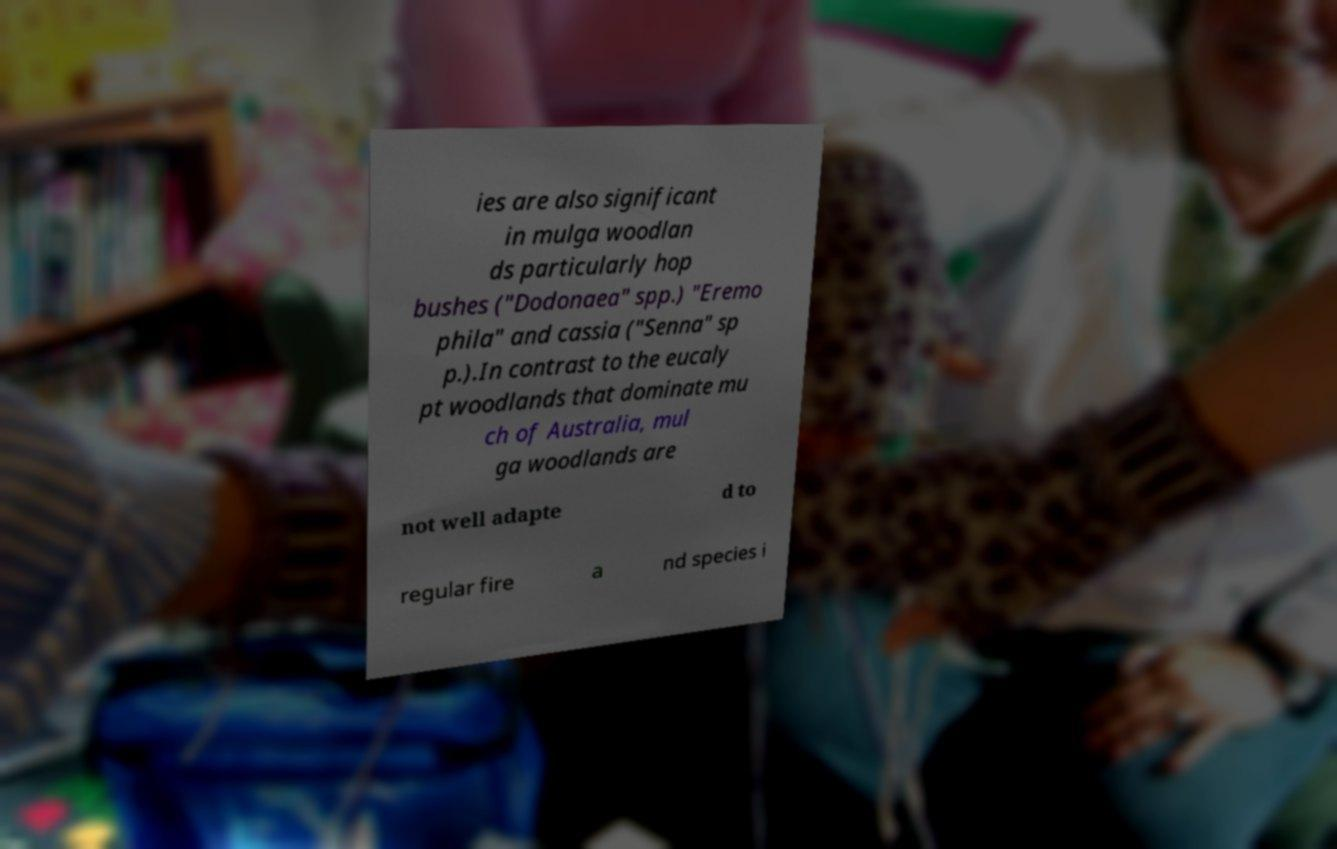Please read and relay the text visible in this image. What does it say? ies are also significant in mulga woodlan ds particularly hop bushes ("Dodonaea" spp.) "Eremo phila" and cassia ("Senna" sp p.).In contrast to the eucaly pt woodlands that dominate mu ch of Australia, mul ga woodlands are not well adapte d to regular fire a nd species i 